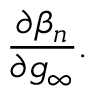<formula> <loc_0><loc_0><loc_500><loc_500>\frac { \partial \beta _ { n } } { \partial g _ { \infty } } .</formula> 